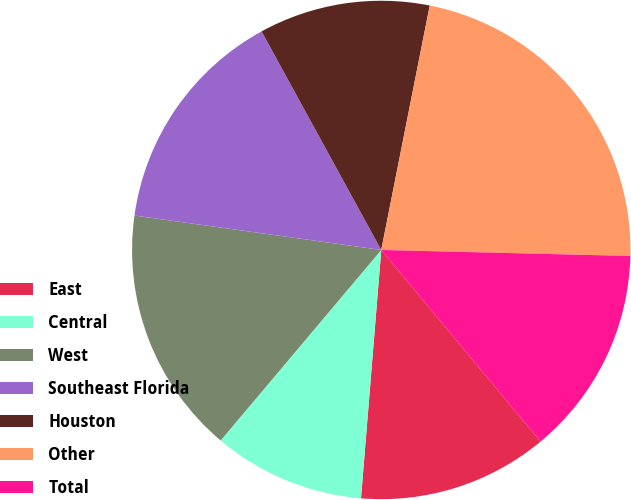<chart> <loc_0><loc_0><loc_500><loc_500><pie_chart><fcel>East<fcel>Central<fcel>West<fcel>Southeast Florida<fcel>Houston<fcel>Other<fcel>Total<nl><fcel>12.33%<fcel>9.85%<fcel>16.06%<fcel>14.82%<fcel>11.09%<fcel>22.27%<fcel>13.58%<nl></chart> 